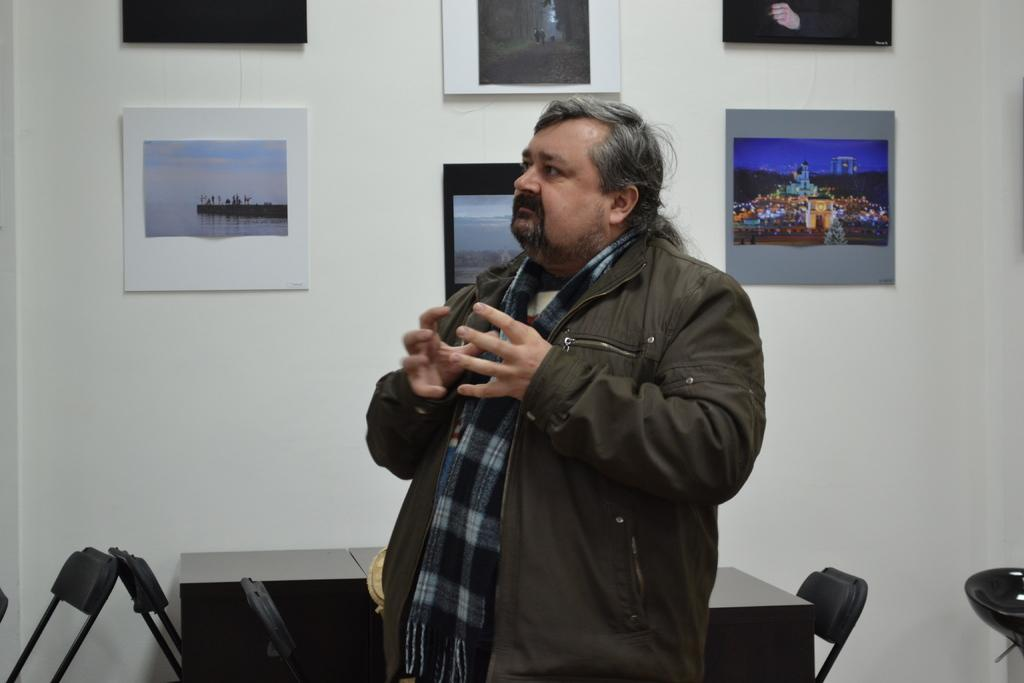What is the person in the image wearing? The person is wearing a jacket in the image. Where is the person located in the image? The person is in the center of the image. What can be seen in the background of the image? There is a wall with a poster on it in the background of the image. What furniture is present in the image? There is a table and chairs in the image. What type of oatmeal is the person cooking in the image? There is no oatmeal or cooking activity present in the image. 